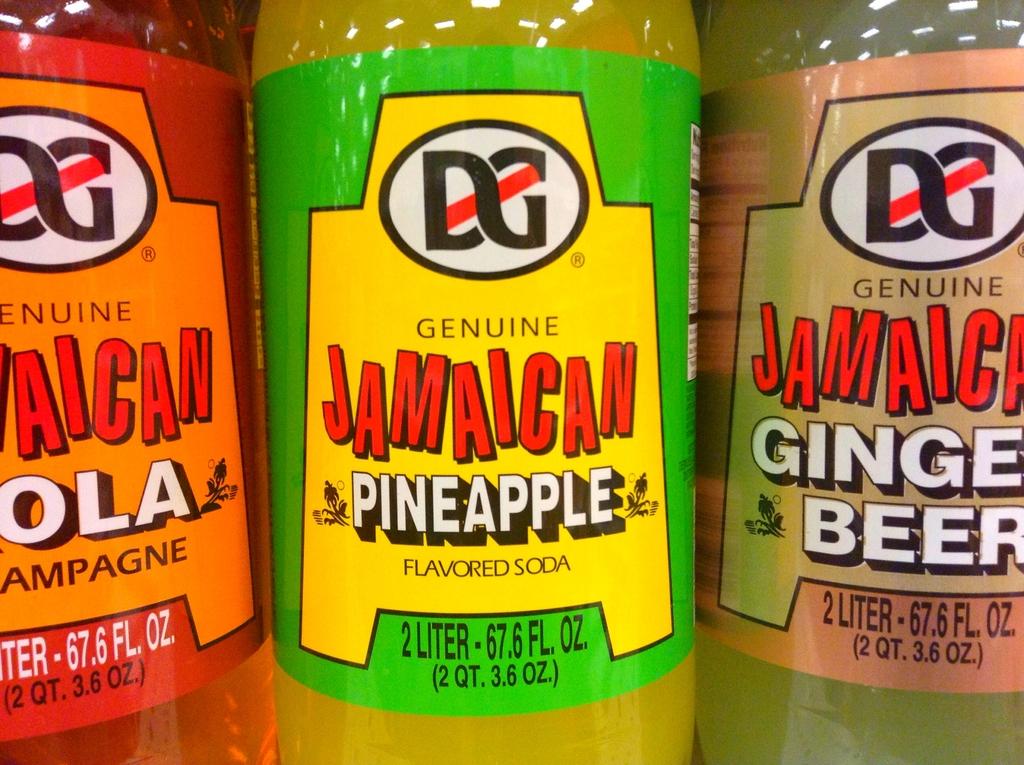How many liters is the beverage in the middle?
Your response must be concise. 2. What is the brand name of the beer on the right?
Keep it short and to the point. Dg. 